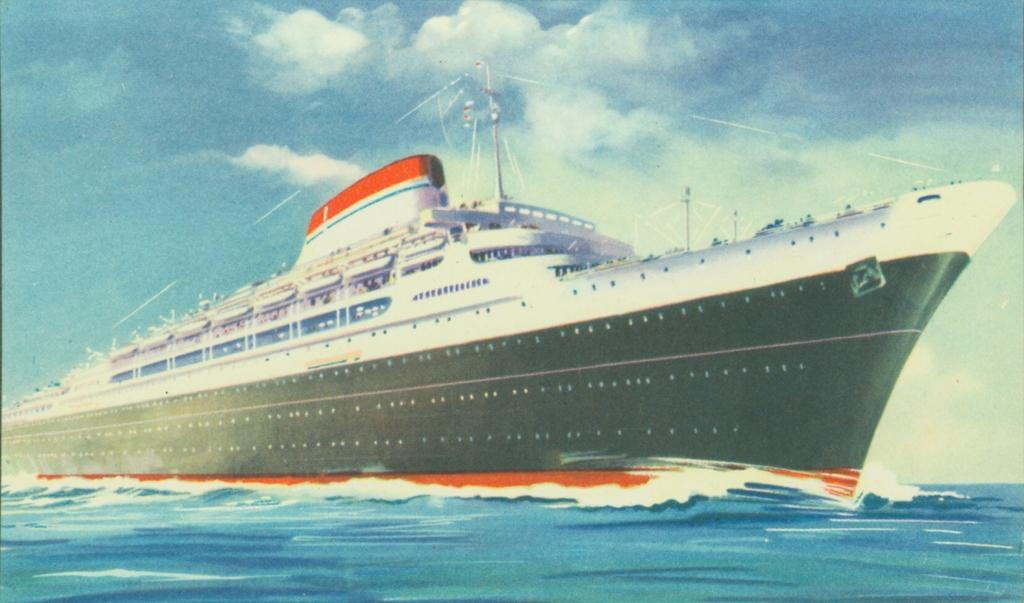What is the main subject of the image? The main subject of the image is a ship above the water. What other objects can be seen in the image? There are poles with strings in the image. What is visible in the background of the image? The sky is visible in the background of the image. What can be observed in the sky? Clouds are present in the sky. What type of mine is visible in the image? There is no mine present in the image. What thoughts are the clouds having in the image? Clouds do not have thoughts, as they are inanimate objects. 